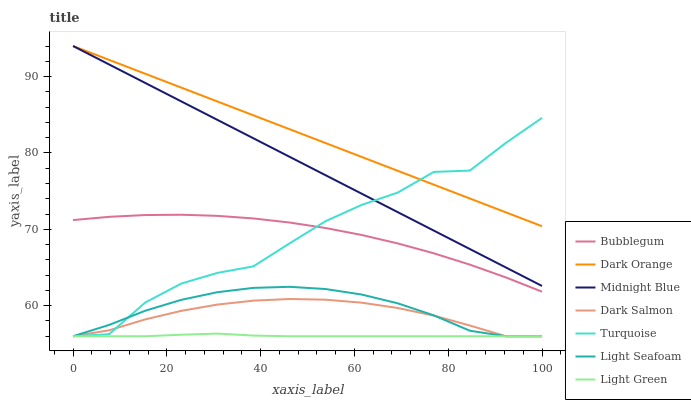Does Light Green have the minimum area under the curve?
Answer yes or no. Yes. Does Dark Orange have the maximum area under the curve?
Answer yes or no. Yes. Does Turquoise have the minimum area under the curve?
Answer yes or no. No. Does Turquoise have the maximum area under the curve?
Answer yes or no. No. Is Dark Orange the smoothest?
Answer yes or no. Yes. Is Turquoise the roughest?
Answer yes or no. Yes. Is Midnight Blue the smoothest?
Answer yes or no. No. Is Midnight Blue the roughest?
Answer yes or no. No. Does Turquoise have the lowest value?
Answer yes or no. Yes. Does Midnight Blue have the lowest value?
Answer yes or no. No. Does Midnight Blue have the highest value?
Answer yes or no. Yes. Does Turquoise have the highest value?
Answer yes or no. No. Is Dark Salmon less than Dark Orange?
Answer yes or no. Yes. Is Dark Orange greater than Bubblegum?
Answer yes or no. Yes. Does Dark Orange intersect Midnight Blue?
Answer yes or no. Yes. Is Dark Orange less than Midnight Blue?
Answer yes or no. No. Is Dark Orange greater than Midnight Blue?
Answer yes or no. No. Does Dark Salmon intersect Dark Orange?
Answer yes or no. No. 